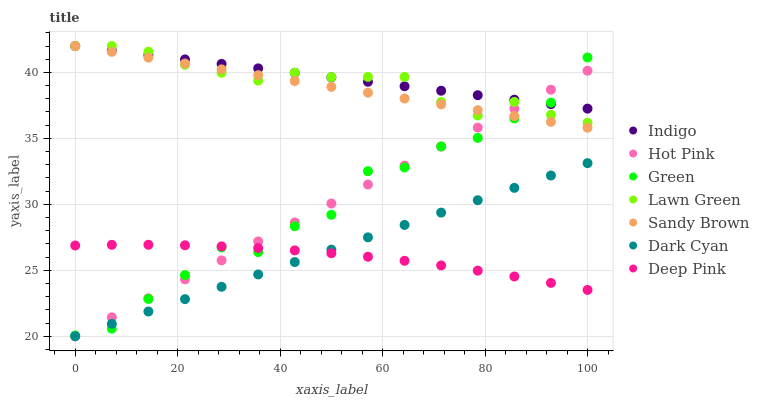Does Deep Pink have the minimum area under the curve?
Answer yes or no. Yes. Does Indigo have the maximum area under the curve?
Answer yes or no. Yes. Does Indigo have the minimum area under the curve?
Answer yes or no. No. Does Deep Pink have the maximum area under the curve?
Answer yes or no. No. Is Hot Pink the smoothest?
Answer yes or no. Yes. Is Green the roughest?
Answer yes or no. Yes. Is Deep Pink the smoothest?
Answer yes or no. No. Is Deep Pink the roughest?
Answer yes or no. No. Does Hot Pink have the lowest value?
Answer yes or no. Yes. Does Deep Pink have the lowest value?
Answer yes or no. No. Does Sandy Brown have the highest value?
Answer yes or no. Yes. Does Deep Pink have the highest value?
Answer yes or no. No. Is Deep Pink less than Lawn Green?
Answer yes or no. Yes. Is Lawn Green greater than Dark Cyan?
Answer yes or no. Yes. Does Green intersect Lawn Green?
Answer yes or no. Yes. Is Green less than Lawn Green?
Answer yes or no. No. Is Green greater than Lawn Green?
Answer yes or no. No. Does Deep Pink intersect Lawn Green?
Answer yes or no. No. 